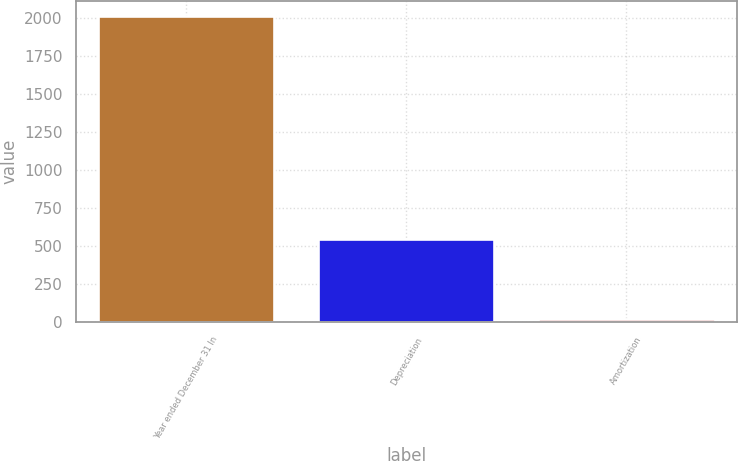Convert chart to OTSL. <chart><loc_0><loc_0><loc_500><loc_500><bar_chart><fcel>Year ended December 31 In<fcel>Depreciation<fcel>Amortization<nl><fcel>2013<fcel>546<fcel>23<nl></chart> 